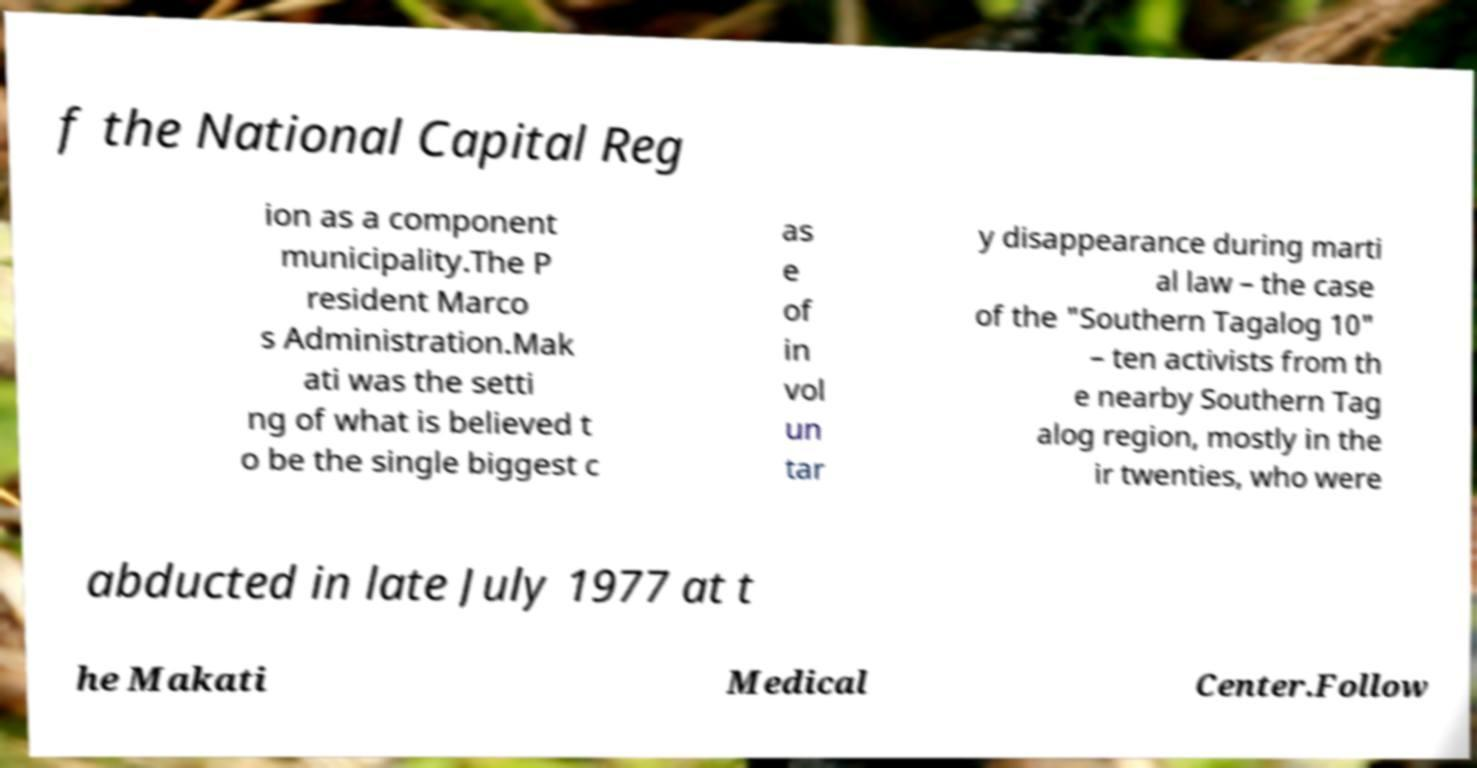There's text embedded in this image that I need extracted. Can you transcribe it verbatim? f the National Capital Reg ion as a component municipality.The P resident Marco s Administration.Mak ati was the setti ng of what is believed t o be the single biggest c as e of in vol un tar y disappearance during marti al law – the case of the "Southern Tagalog 10" – ten activists from th e nearby Southern Tag alog region, mostly in the ir twenties, who were abducted in late July 1977 at t he Makati Medical Center.Follow 